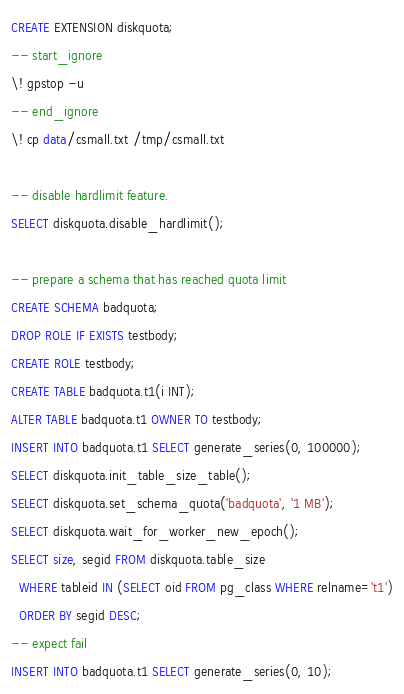<code> <loc_0><loc_0><loc_500><loc_500><_SQL_>CREATE EXTENSION diskquota;
-- start_ignore
\! gpstop -u
-- end_ignore
\! cp data/csmall.txt /tmp/csmall.txt

-- disable hardlimit feature.
SELECT diskquota.disable_hardlimit();

-- prepare a schema that has reached quota limit
CREATE SCHEMA badquota;
DROP ROLE IF EXISTS testbody;
CREATE ROLE testbody;
CREATE TABLE badquota.t1(i INT);
ALTER TABLE badquota.t1 OWNER TO testbody;
INSERT INTO badquota.t1 SELECT generate_series(0, 100000);
SELECT diskquota.init_table_size_table();
SELECT diskquota.set_schema_quota('badquota', '1 MB');
SELECT diskquota.wait_for_worker_new_epoch();
SELECT size, segid FROM diskquota.table_size
  WHERE tableid IN (SELECT oid FROM pg_class WHERE relname='t1')
  ORDER BY segid DESC;
-- expect fail
INSERT INTO badquota.t1 SELECT generate_series(0, 10);
</code> 